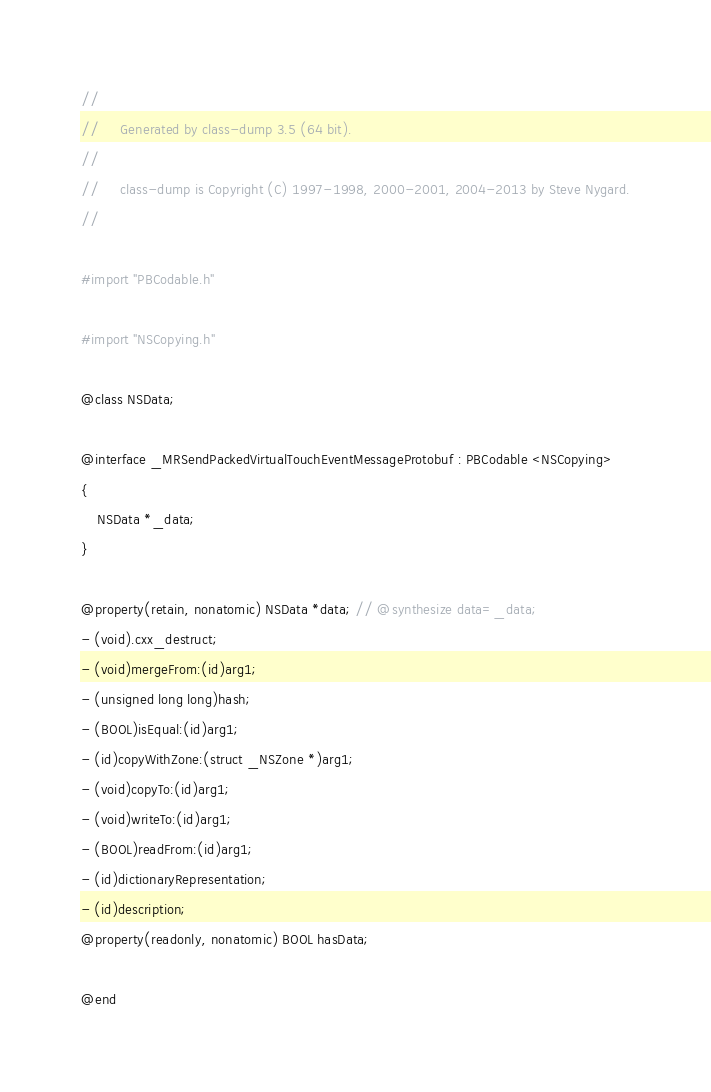Convert code to text. <code><loc_0><loc_0><loc_500><loc_500><_C_>//
//     Generated by class-dump 3.5 (64 bit).
//
//     class-dump is Copyright (C) 1997-1998, 2000-2001, 2004-2013 by Steve Nygard.
//

#import "PBCodable.h"

#import "NSCopying.h"

@class NSData;

@interface _MRSendPackedVirtualTouchEventMessageProtobuf : PBCodable <NSCopying>
{
    NSData *_data;
}

@property(retain, nonatomic) NSData *data; // @synthesize data=_data;
- (void).cxx_destruct;
- (void)mergeFrom:(id)arg1;
- (unsigned long long)hash;
- (BOOL)isEqual:(id)arg1;
- (id)copyWithZone:(struct _NSZone *)arg1;
- (void)copyTo:(id)arg1;
- (void)writeTo:(id)arg1;
- (BOOL)readFrom:(id)arg1;
- (id)dictionaryRepresentation;
- (id)description;
@property(readonly, nonatomic) BOOL hasData;

@end

</code> 